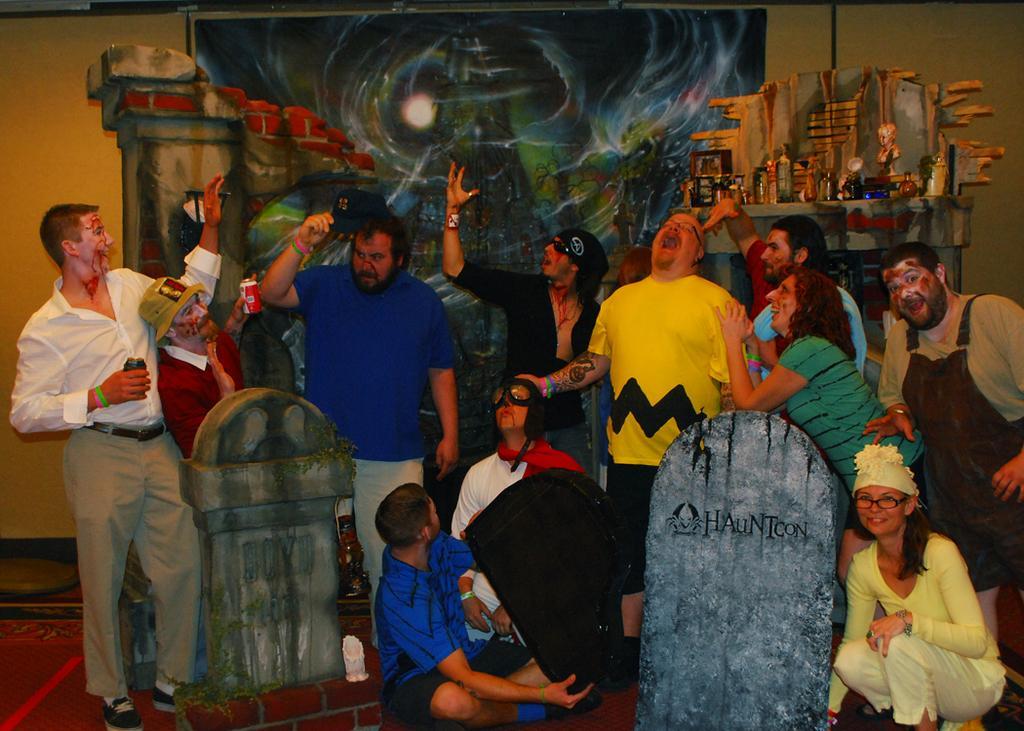Please provide a concise description of this image. In the foreground of this image, there are people standing, squatting and sitting on the floor and there are depicted headstones and the wall. We can also see few objects on a depicted wall. In the background, there is a banner to the wall. 